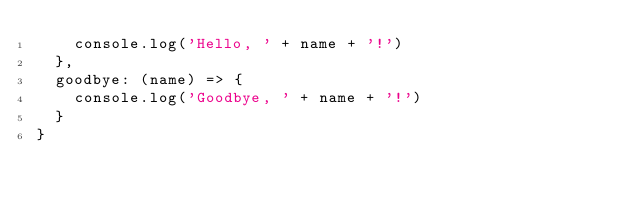<code> <loc_0><loc_0><loc_500><loc_500><_JavaScript_>    console.log('Hello, ' + name + '!')
  },
  goodbye: (name) => {
    console.log('Goodbye, ' + name + '!')
  }
}
</code> 